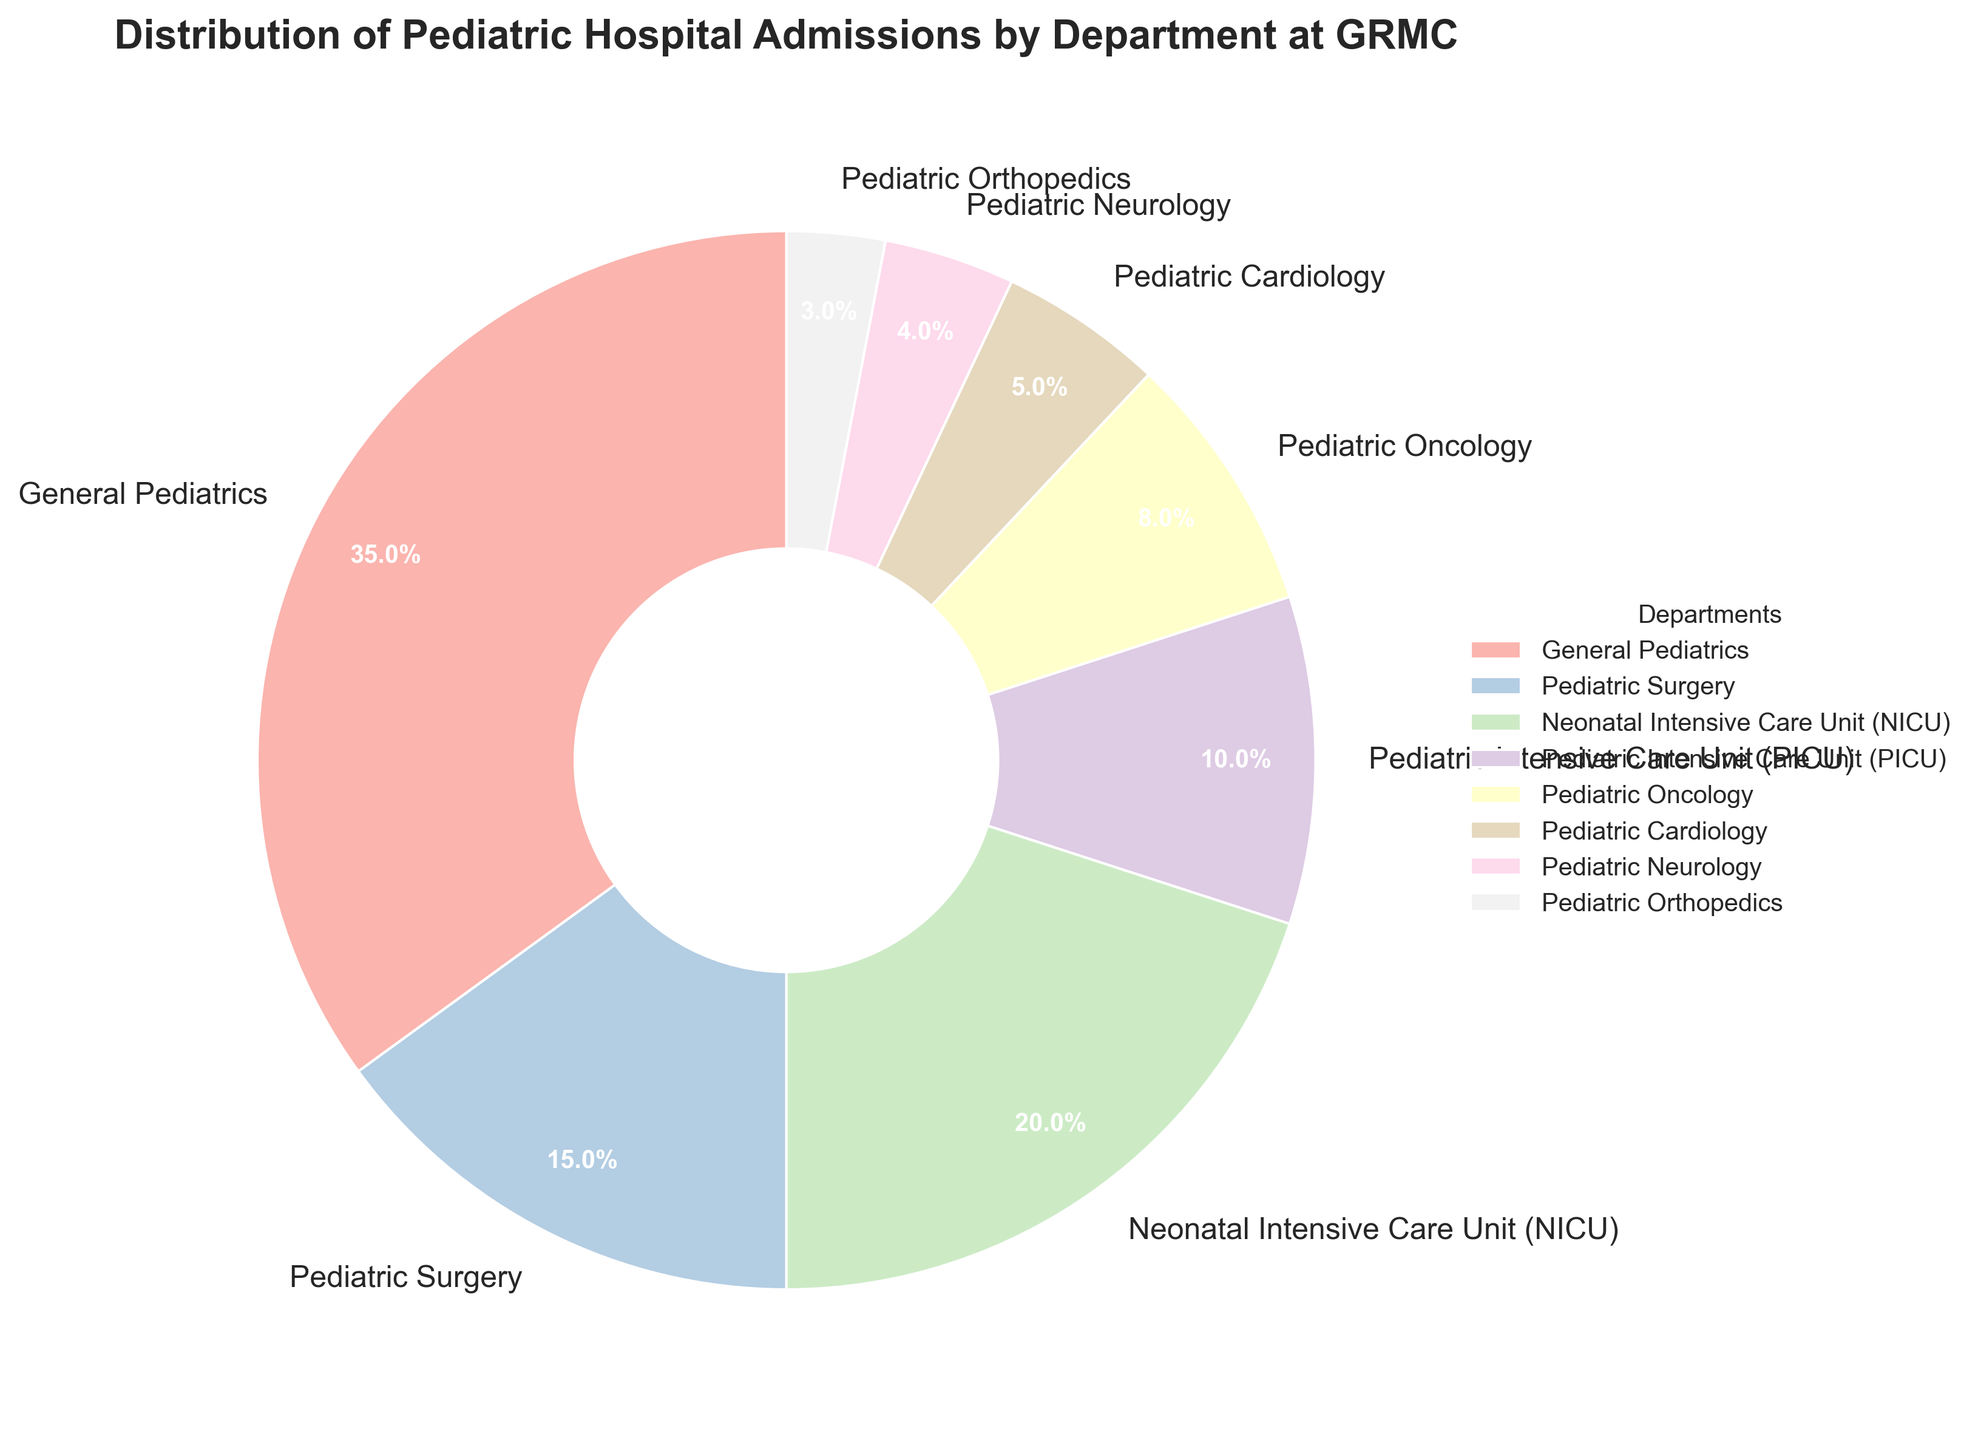Which department has the highest percentage of pediatric hospital admissions at GRMC? Look at the department with the largest section in the pie chart. The "General Pediatrics" section is the largest.
Answer: General Pediatrics What is the combined percentage of admissions for the NICU and PICU departments? Add the percentages for NICU and PICU: 20% (NICU) + 10% (PICU) = 30%
Answer: 30% How does the percentage of admissions for Pediatric Oncology compare to Pediatric Neurology? Compare the sizes of the sections. Pediatric Oncology has 8%, which is larger than Pediatric Neurology's 4%.
Answer: Pediatric Oncology has a higher percentage Which department has a higher percentage of admissions: Pediatric Surgery or Pediatric Cardiology? Compare the sections for Pediatric Surgery and Pediatric Cardiology. Pediatric Surgery has 15%, and Pediatric Cardiology has 5%.
Answer: Pediatric Surgery What is the total percentage of admissions for the departments with less than 5% each? Sum the percentages for departments with less than 5%: Pediatric Neurology (4%) + Pediatric Orthopedics (3%) = 7%
Answer: 7% Which department has the smallest percentage of pediatric hospital admissions? Identify the smallest section in the pie chart, which is Pediatric Orthopedics at 3%.
Answer: Pediatric Orthopedics How much greater is the percentage of admissions for General Pediatrics compared to the Pediatric Intensive Care Unit (PICU)? Subtract the percentage of PICU from General Pediatrics: 35% (General Pediatrics) - 10% (PICU) = 25%
Answer: 25% Is the percentage of admissions for the Pediatric Intensive Care Unit (PICU) equal to the combined percentage of Pediatric Cardiology and Pediatric Neurology? Calculate the total for Pediatric Cardiology and Pediatric Neurology: 5% + 4% = 9%. Compare it with PICU's 10%.
Answer: No How many departments have a percentage of admissions of 10% or higher? Count the sections that are 10% or higher: General Pediatrics (35%), Pediatric Surgery (15%), NICU (20%), PICU (10%).
Answer: 4 If admissions for Pediatric Orthopedics increased by 2%, what would its new percentage be? Add 2% to the current percentage of Pediatric Orthopedics: 3% + 2% = 5%
Answer: 5% 